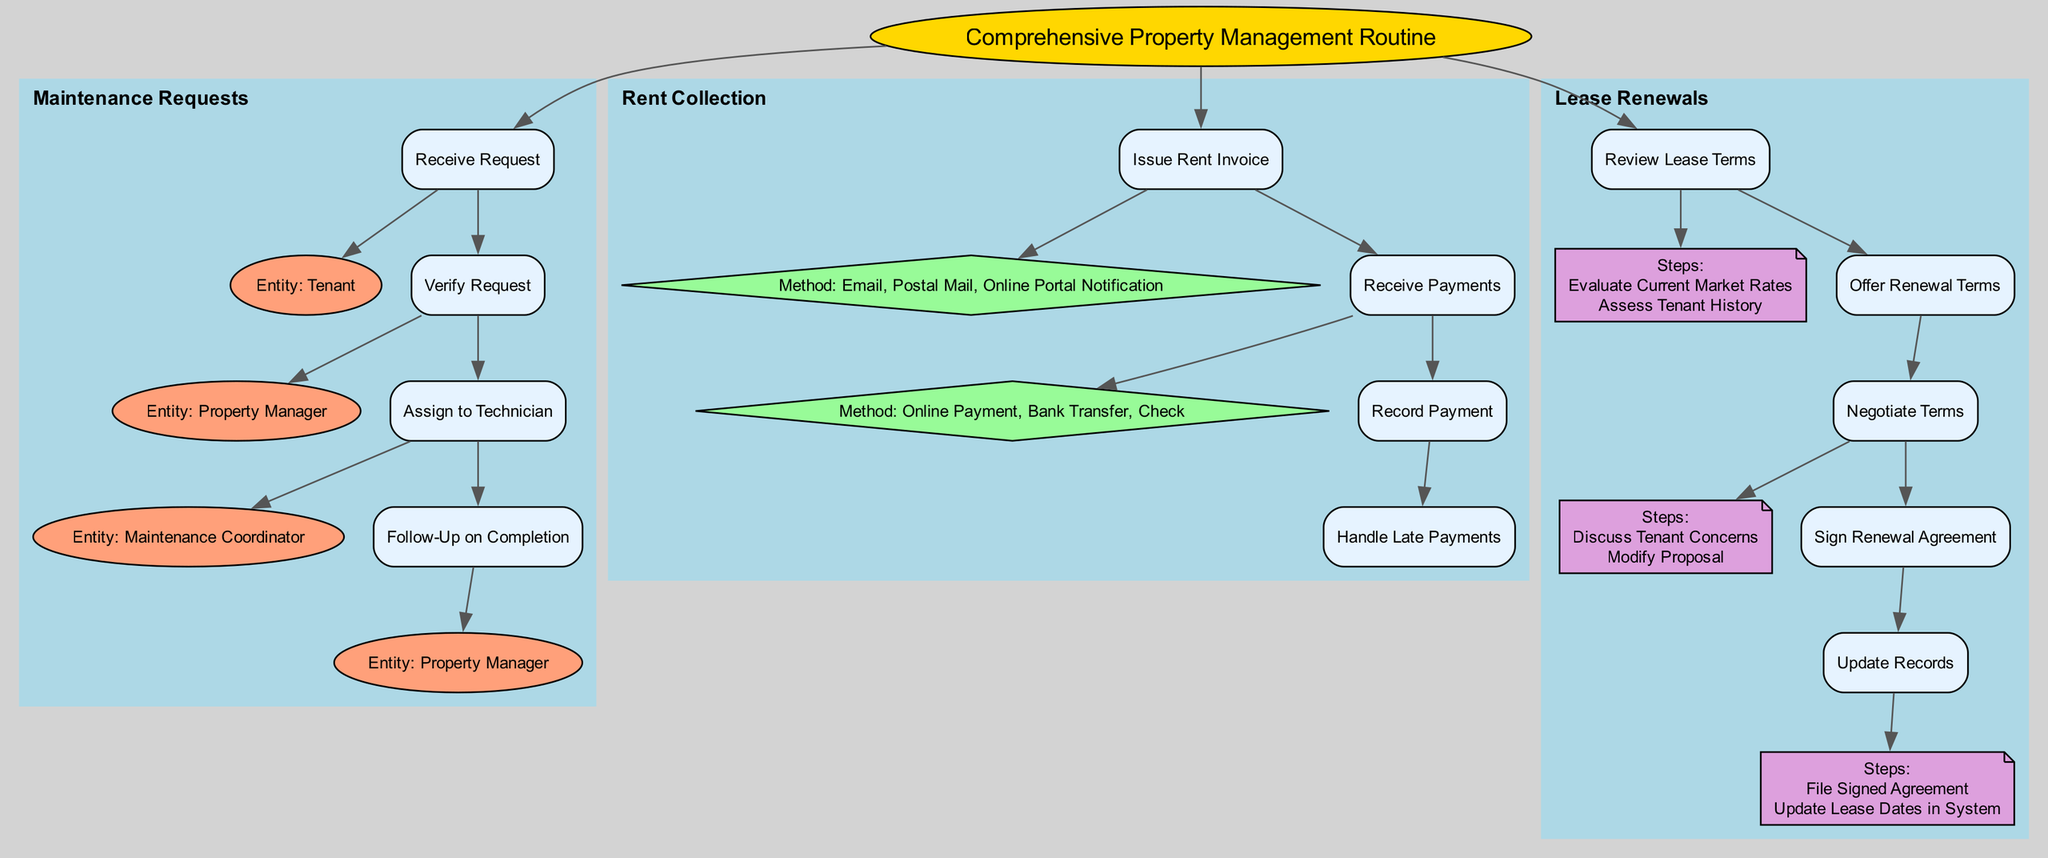What is the first step in Handling Maintenance Requests? The first step in the Maintenance Requests section is "Receive Request," which is indicated as the entry point of the workflow in this section of the diagram.
Answer: Receive Request Which entity is responsible for verifying the maintenance request? The diagram shows that the "Property Manager" is the entity assigned to the "Verify Request" step in the Maintenance Requests section.
Answer: Property Manager How many methods are available for issuing a rent invoice? In the Rent Collection section, there are three methods listed for issuing a rent invoice: Email, Postal Mail, and Online Portal Notification. The diagram clearly shows these methods under the "Issue Rent Invoice" step.
Answer: 3 What steps are involved in handling late payments? The flow chart outlines two specific steps under the "Handle Late Payments" task: "Issue Late Fee Notice" and "Arrange Payment Plan," indicating the procedure for addressing late payments.
Answer: Issue Late Fee Notice, Arrange Payment Plan Who is involved in negotiating lease renewal terms? The diagram specifies that both the "Property Manager" and the "Tenant" are involved in the "Negotiate Terms" step of the Lease Renewals process, highlighting a collaborative aspect of lease discussions.
Answer: Property Manager, Tenant What is the final step in the Lease Renewals section? The last step outlined in the Lease Renewals section is "Update Records," indicating that finalizing the lease renewal involves updating relevant records after signing the agreement.
Answer: Update Records What method is used for signing the renewal agreement? According to the diagram, the renewal agreement can be signed using either "Electronic Signature" or "In-Person Signing," which are presented as options under the "Sign Renewal Agreement" step.
Answer: Electronic Signature, In-Person Signing Which entity issues the rent invoice? The "Property Management System" is the entity responsible for issuing the rent invoice, as noted under the "Issue Rent Invoice" task in the Rent Collection section.
Answer: Property Management System Which task follows "Receive Request" in the Maintenance Requests process? The task that follows "Receive Request" is "Verify Request," which indicates the progression from receiving the maintenance request to its verification step.
Answer: Verify Request 